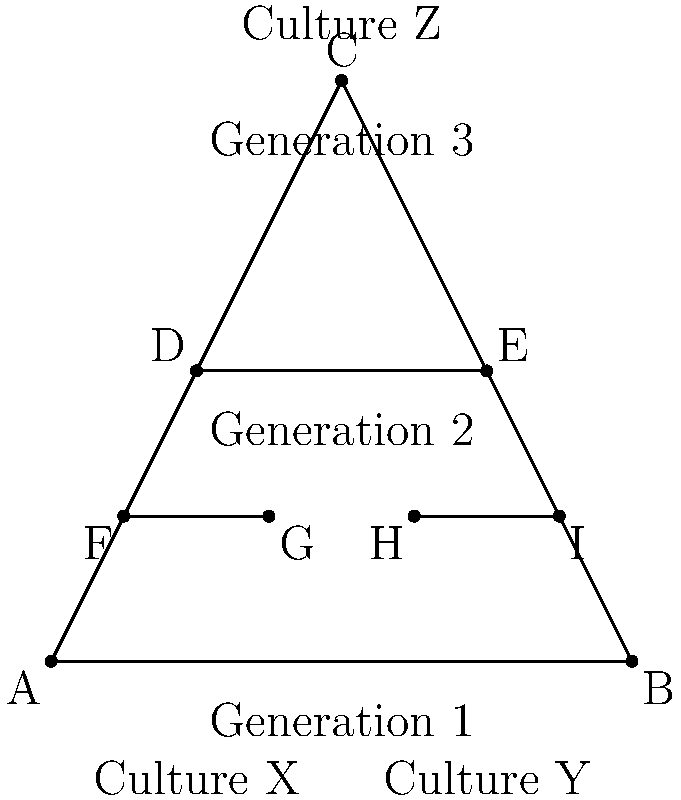In the family tree diagram representing multicultural heritage, which segments are congruent to segment FG? Select all that apply.

a) DE
b) HI
c) AB
d) AC To determine which segments are congruent to FG, we need to analyze the diagram and consider the properties of congruent segments. Let's go through this step-by-step:

1) Segment FG represents a connection between two individuals in the third generation of the family tree.

2) Segment HI is parallel to FG and appears to be the same length. In a family tree diagram like this, segments representing the same generation are typically drawn to be congruent. Therefore, HI is congruent to FG.

3) Segment DE represents the second generation and appears to be twice the length of FG. It is not congruent to FG.

4) Segment AB represents the first generation and is the base of the triangle. It is clearly longer than FG and not congruent to it.

5) Segment AC is one of the sides of the triangle representing the entire family tree. It is much longer than FG and not congruent to it.

Therefore, based on the visual representation and the typical conventions of family tree diagrams, only segment HI is congruent to segment FG.
Answer: b 